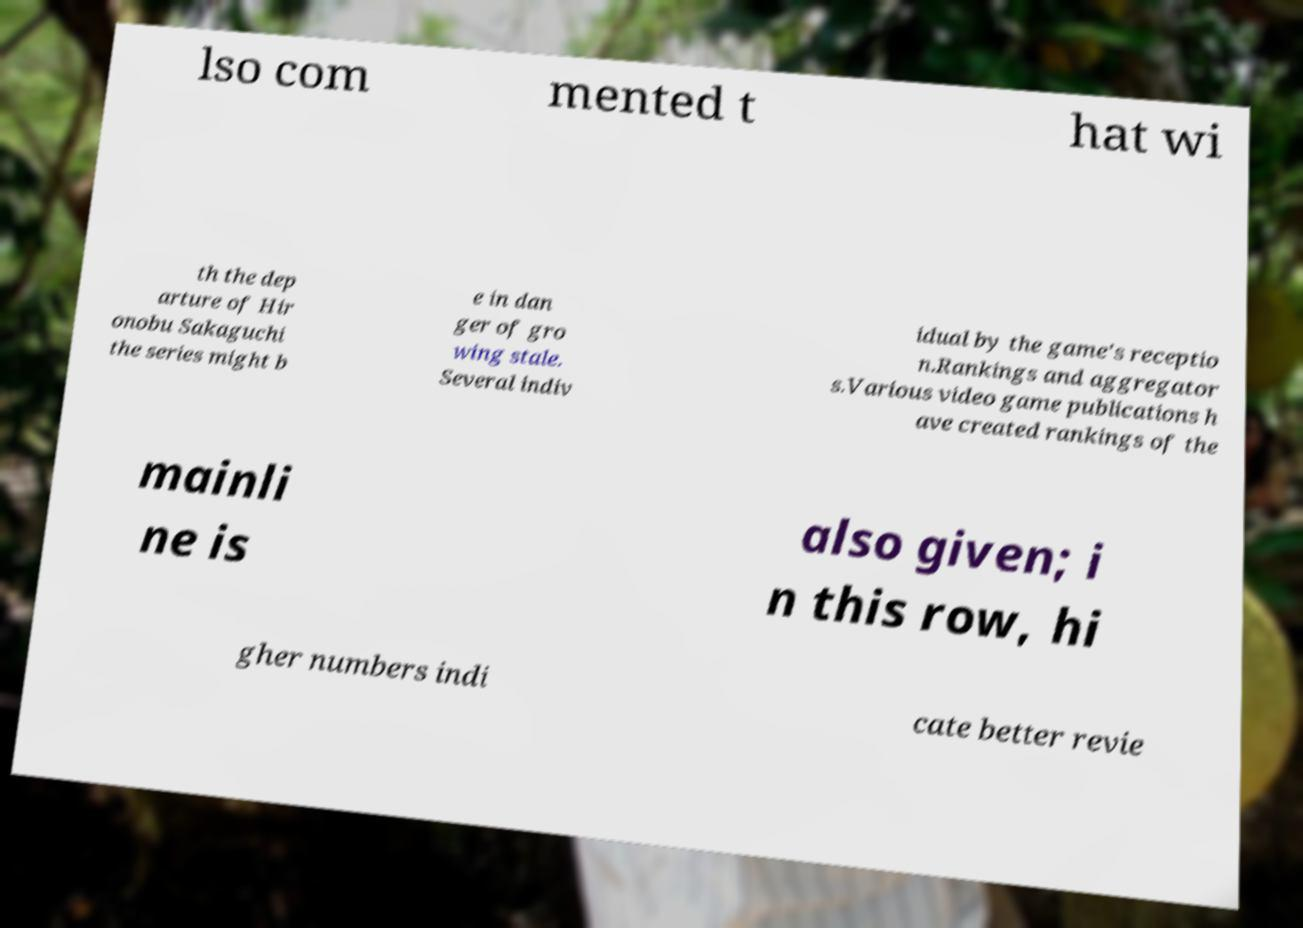There's text embedded in this image that I need extracted. Can you transcribe it verbatim? lso com mented t hat wi th the dep arture of Hir onobu Sakaguchi the series might b e in dan ger of gro wing stale. Several indiv idual by the game's receptio n.Rankings and aggregator s.Various video game publications h ave created rankings of the mainli ne is also given; i n this row, hi gher numbers indi cate better revie 